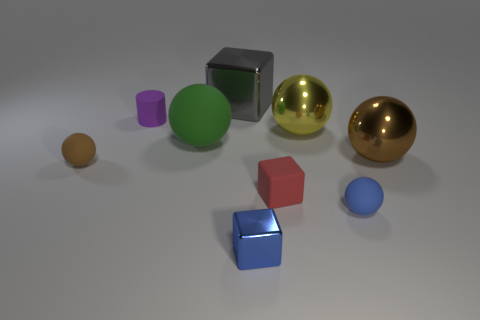Is there any other thing that is the same color as the small metallic thing?
Offer a very short reply. Yes. There is a green thing that is made of the same material as the purple cylinder; what shape is it?
Give a very brief answer. Sphere. There is a purple object; is it the same shape as the brown object that is on the left side of the green ball?
Your answer should be very brief. No. What is the block that is behind the tiny rubber sphere that is to the left of the gray shiny thing made of?
Provide a short and direct response. Metal. Are there an equal number of metal cubes that are left of the large matte thing and big brown matte things?
Offer a very short reply. Yes. There is a small matte sphere that is to the left of the large gray block; does it have the same color as the large thing that is in front of the green matte object?
Give a very brief answer. Yes. What number of big objects are in front of the gray object and behind the large green matte object?
Your answer should be compact. 1. How many other objects are the same shape as the purple thing?
Provide a succinct answer. 0. Are there more cylinders that are behind the large brown metallic object than brown cylinders?
Provide a succinct answer. Yes. What is the color of the small matte ball that is on the right side of the tiny purple cylinder?
Provide a succinct answer. Blue. 